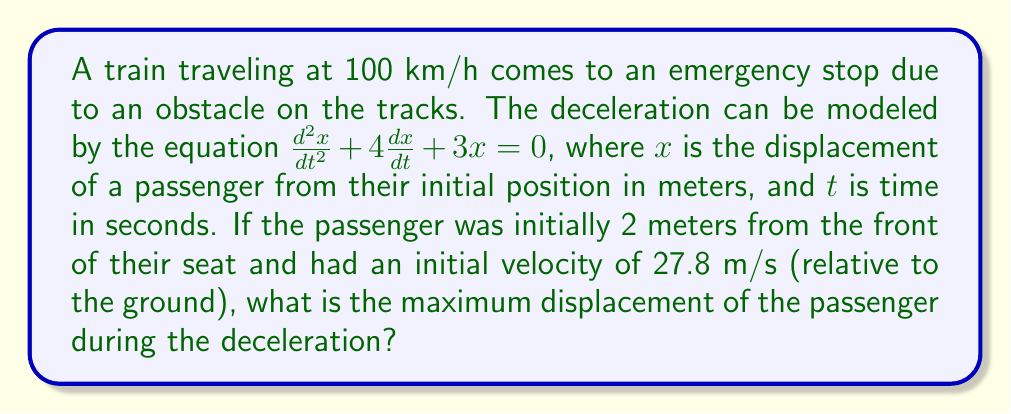Solve this math problem. To solve this problem, we need to follow these steps:

1) First, we recognize this as a second-order linear differential equation with constant coefficients. The general solution has the form:

   $x(t) = c_1e^{r_1t} + c_2e^{r_2t}$

   where $r_1$ and $r_2$ are the roots of the characteristic equation.

2) The characteristic equation is:
   
   $r^2 + 4r + 3 = 0$

3) Solving this equation:
   
   $r = \frac{-4 \pm \sqrt{16 - 12}}{2} = \frac{-4 \pm \sqrt{4}}{2} = \frac{-4 \pm 2}{2}$

   So, $r_1 = -1$ and $r_2 = -3$

4) Therefore, the general solution is:

   $x(t) = c_1e^{-t} + c_2e^{-3t}$

5) To find $c_1$ and $c_2$, we use the initial conditions:

   At $t=0$, $x(0) = 2$ and $\frac{dx}{dt}(0) = 27.8$

6) From $x(0) = 2$:
   
   $2 = c_1 + c_2$

7) From $\frac{dx}{dt}(0) = 27.8$:
   
   $27.8 = -c_1 - 3c_2$

8) Solving these equations:

   $c_1 = 14.9$ and $c_2 = -12.9$

9) So, the particular solution is:

   $x(t) = 14.9e^{-t} - 12.9e^{-3t}$

10) To find the maximum displacement, we differentiate $x(t)$ and set it to zero:

    $\frac{dx}{dt} = -14.9e^{-t} + 38.7e^{-3t} = 0$

11) Solving this:

    $e^{2t} = \frac{38.7}{14.9} = 2.597$

    $t = \frac{1}{2}\ln(2.597) = 0.477$ seconds

12) The maximum displacement occurs at this time. Plugging this back into our solution:

    $x(0.477) = 14.9e^{-0.477} - 12.9e^{-3(0.477)} = 9.51$ meters
Answer: The maximum displacement of the passenger during the deceleration is approximately 9.51 meters. 